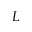<formula> <loc_0><loc_0><loc_500><loc_500>L</formula> 